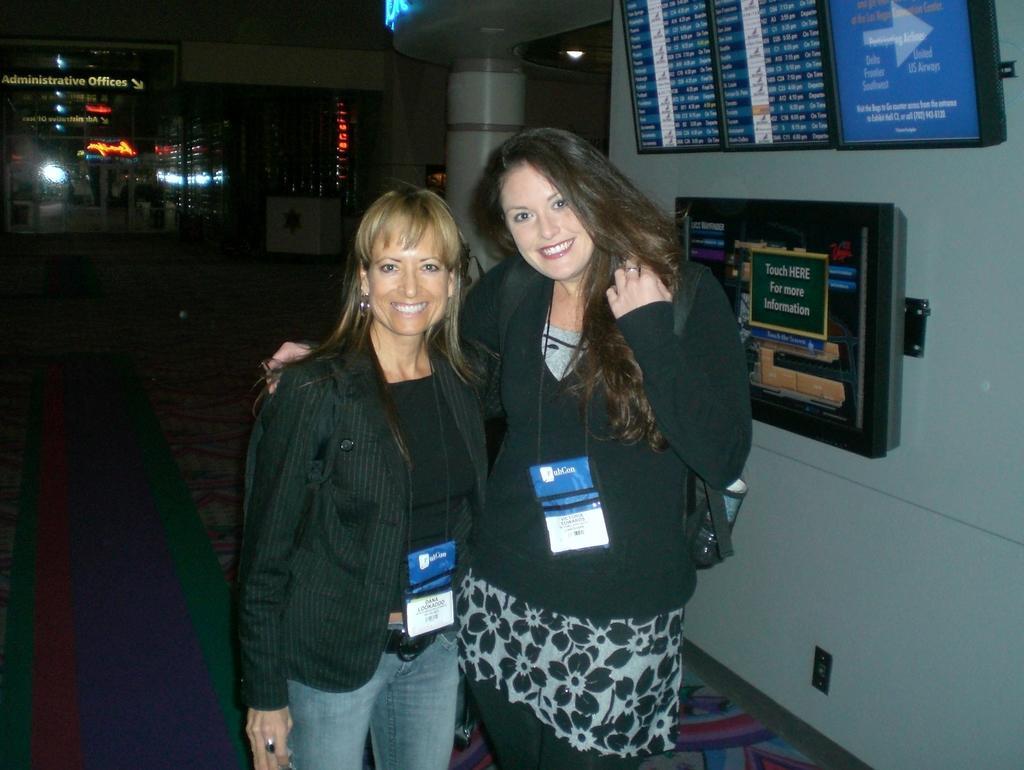Could you give a brief overview of what you see in this image? In this picture there are two girls wearing a black jacket standing in the front, smiling and giving a pose into the camera. Behind there is a blue color notice board. In the background we can see the pillar and dark background. 